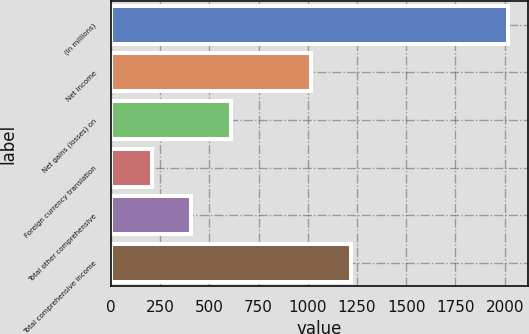<chart> <loc_0><loc_0><loc_500><loc_500><bar_chart><fcel>(In millions)<fcel>Net income<fcel>Net gains (losses) on<fcel>Foreign currency translation<fcel>Total other comprehensive<fcel>Total comprehensive income<nl><fcel>2019<fcel>1019<fcel>610.6<fcel>208.2<fcel>409.4<fcel>1220.2<nl></chart> 